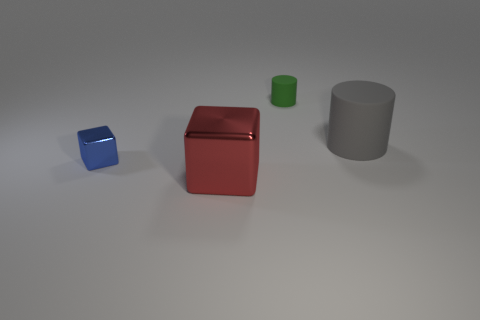Subtract all yellow cubes. Subtract all green cylinders. How many cubes are left? 2 Add 1 green matte cubes. How many objects exist? 5 Add 3 blocks. How many blocks are left? 5 Add 1 blue blocks. How many blue blocks exist? 2 Subtract 0 gray blocks. How many objects are left? 4 Subtract all big gray objects. Subtract all large red matte balls. How many objects are left? 3 